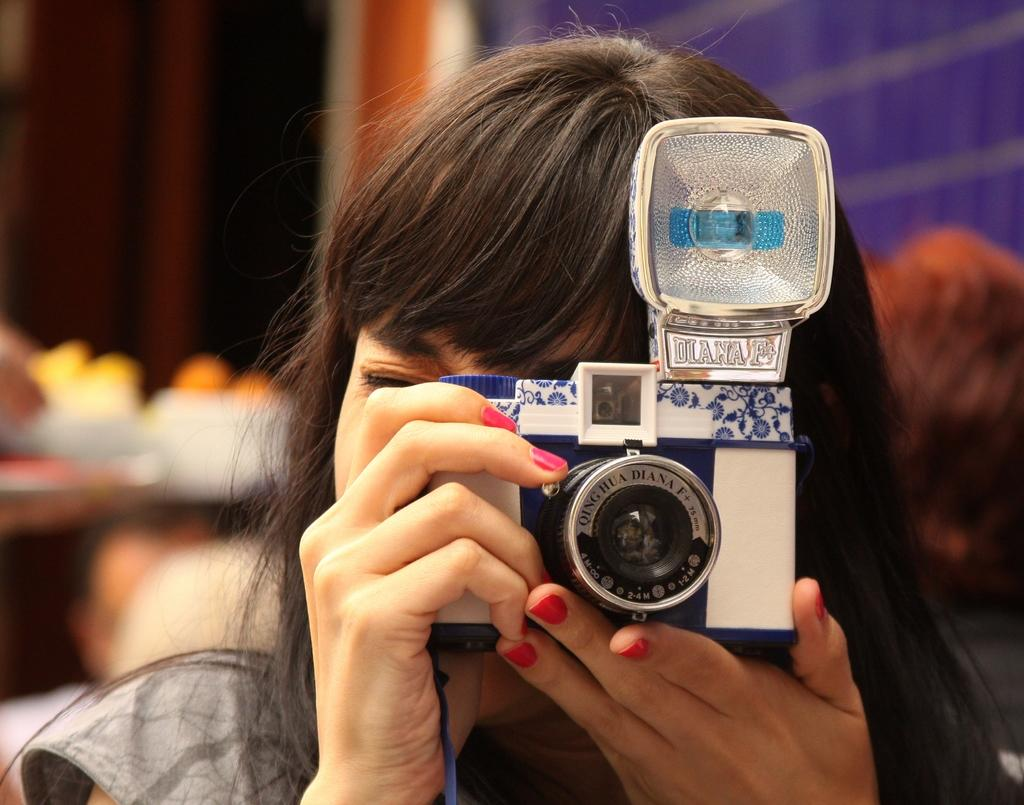<image>
Present a compact description of the photo's key features. A woman is holding a Diana F+ camera up to her eye. 